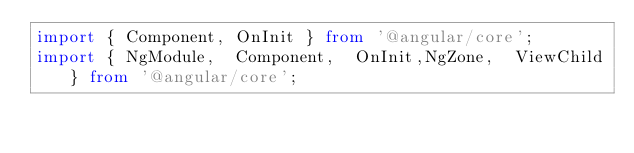Convert code to text. <code><loc_0><loc_0><loc_500><loc_500><_TypeScript_>import { Component, OnInit } from '@angular/core';
import { NgModule,  Component,  OnInit,NgZone,  ViewChild} from '@angular/core';</code> 